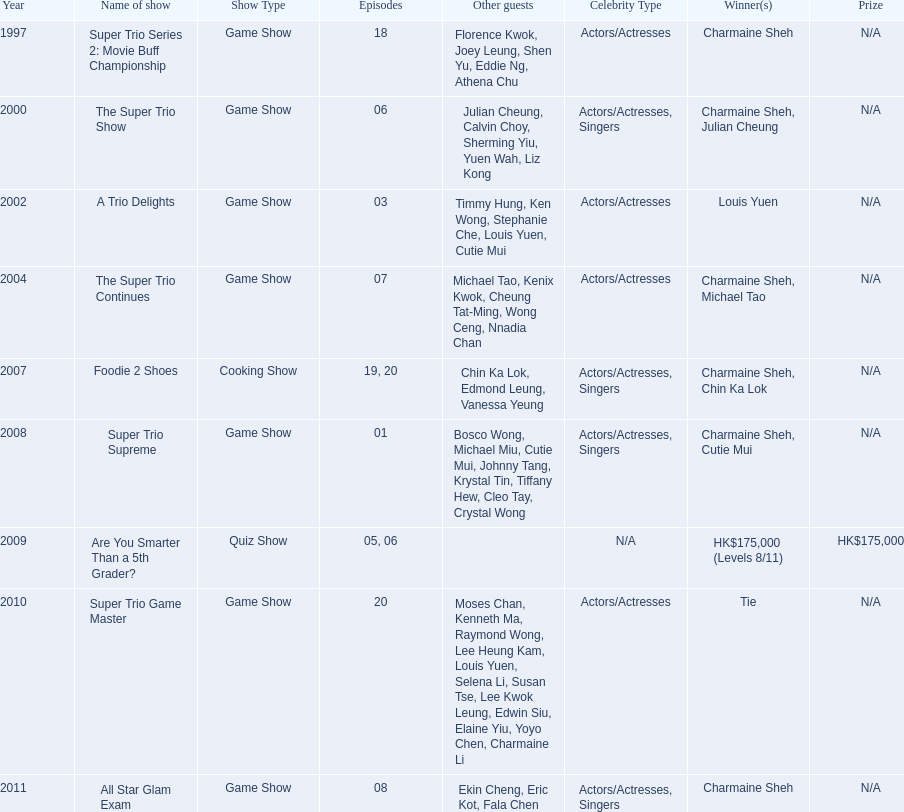What is the number of other guests in the 2002 show "a trio delights"? 5. 